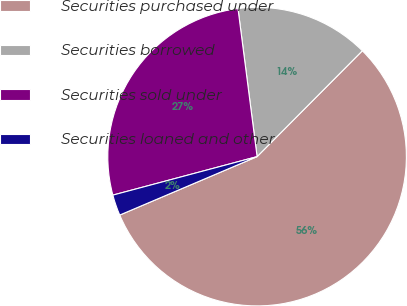<chart> <loc_0><loc_0><loc_500><loc_500><pie_chart><fcel>Securities purchased under<fcel>Securities borrowed<fcel>Securities sold under<fcel>Securities loaned and other<nl><fcel>56.15%<fcel>14.5%<fcel>27.11%<fcel>2.25%<nl></chart> 